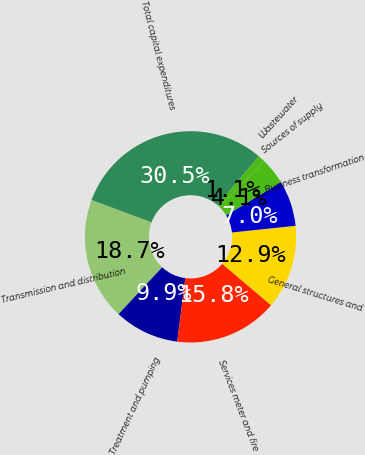Convert chart to OTSL. <chart><loc_0><loc_0><loc_500><loc_500><pie_chart><fcel>Transmission and distribution<fcel>Treatment and pumping<fcel>Services meter and fire<fcel>General structures and<fcel>Business transformation<fcel>Sources of supply<fcel>Wastewater<fcel>Total capital expenditures<nl><fcel>18.74%<fcel>9.93%<fcel>15.8%<fcel>12.87%<fcel>6.99%<fcel>4.05%<fcel>1.12%<fcel>30.49%<nl></chart> 